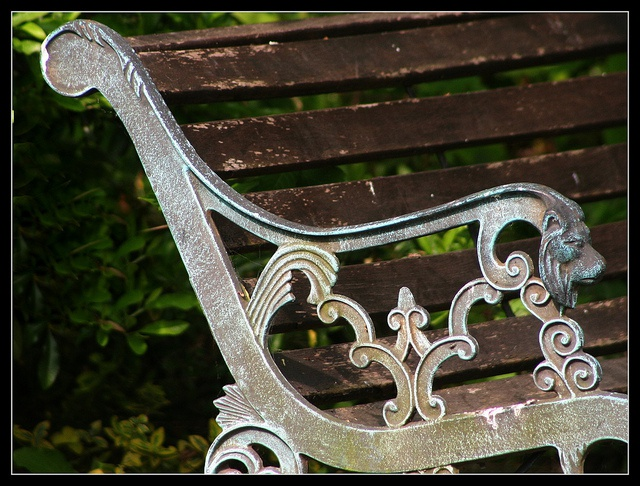Describe the objects in this image and their specific colors. I can see a bench in black, darkgray, and gray tones in this image. 